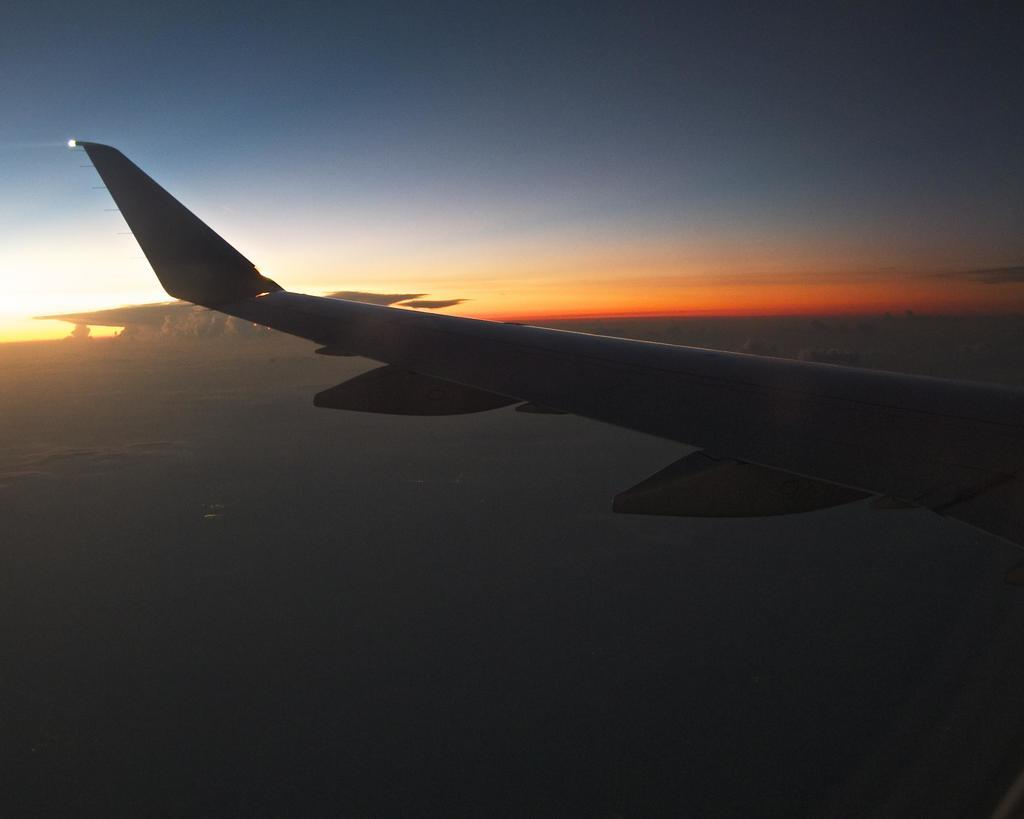What is the main subject of the image? The main subject of the image is the wing of a plane. Where is the wing of the plane located? The wing of the plane is in the air. What can be seen in the background of the image? There are clouds visible in the sky in the background of the image. What month is it in the image? The month cannot be determined from the image, as there is no information about the time of year. How many yams are present in the image? There are no yams present in the image; it features the wing of a plane in the air. 